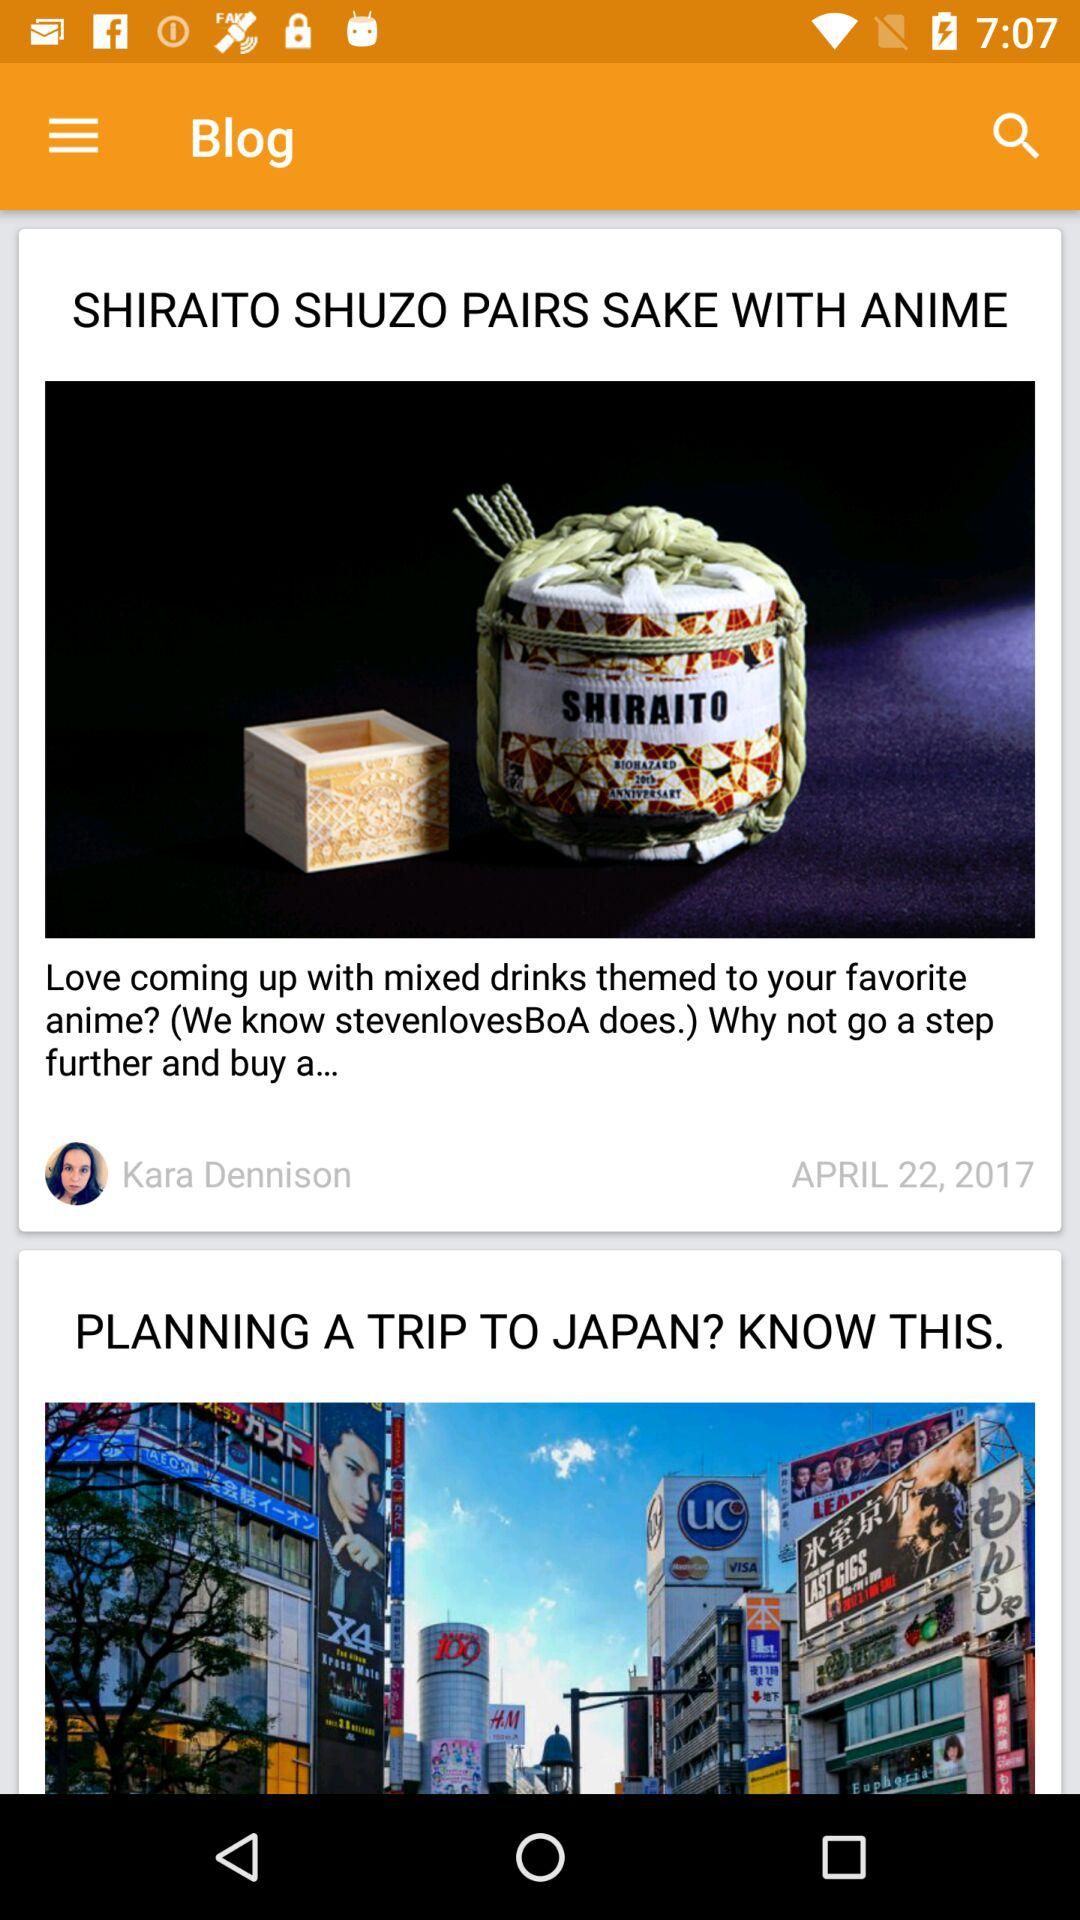Who is the author of the blog "SHIRAITO SHUZO PAIRS SAKE WITH ANIME"? The author of the blog "SHIRAITO SHUZO PAIRS SAKE WITH ANIME" is Kara Dennison. 